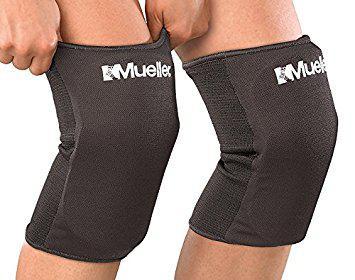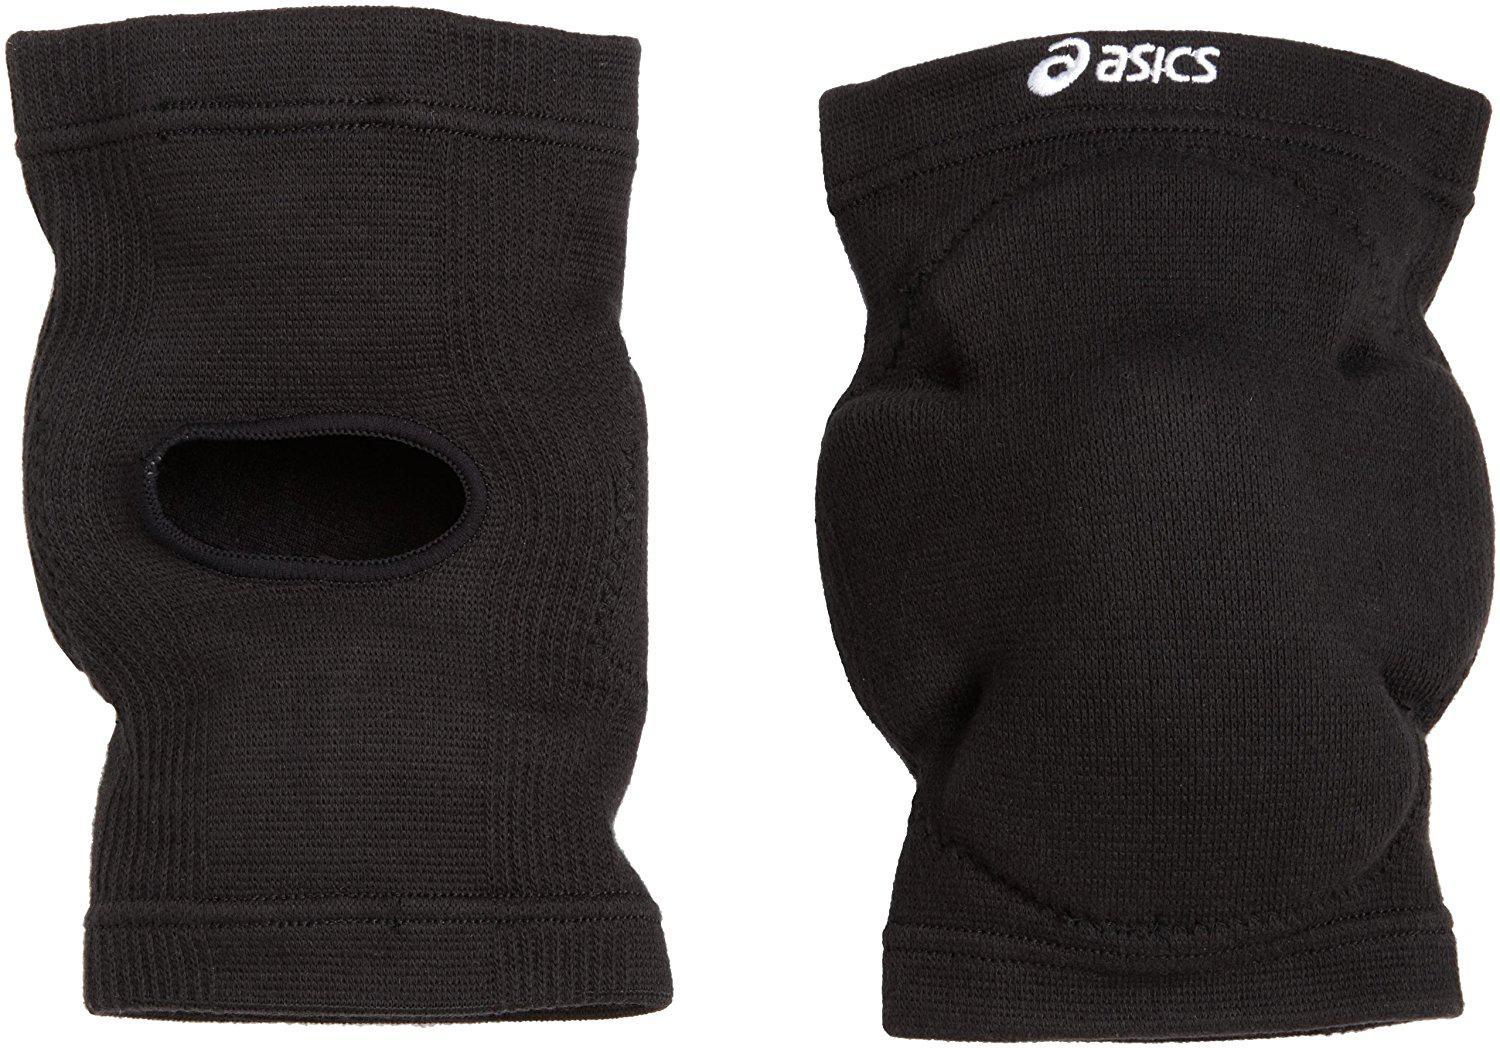The first image is the image on the left, the second image is the image on the right. Analyze the images presented: Is the assertion "The knee braces in the left image are facing towards the left." valid? Answer yes or no. No. The first image is the image on the left, the second image is the image on the right. Evaluate the accuracy of this statement regarding the images: "One image contains at least three legs wearing different kneepads.". Is it true? Answer yes or no. No. 